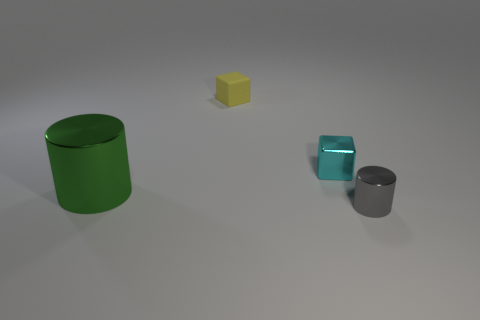Add 2 cyan metallic objects. How many objects exist? 6 Subtract all cyan cubes. How many cubes are left? 1 Subtract all green cylinders. How many purple cubes are left? 0 Subtract all big cylinders. Subtract all small matte cubes. How many objects are left? 2 Add 3 tiny gray cylinders. How many tiny gray cylinders are left? 4 Add 3 tiny gray rubber balls. How many tiny gray rubber balls exist? 3 Subtract 0 cyan cylinders. How many objects are left? 4 Subtract all brown cylinders. Subtract all cyan balls. How many cylinders are left? 2 